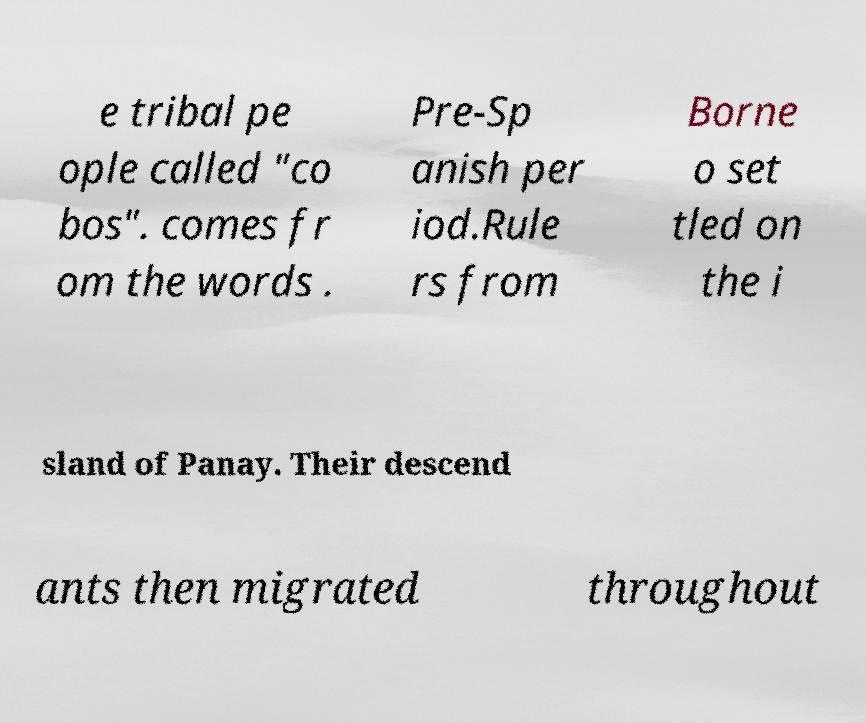Please read and relay the text visible in this image. What does it say? e tribal pe ople called "co bos". comes fr om the words . Pre-Sp anish per iod.Rule rs from Borne o set tled on the i sland of Panay. Their descend ants then migrated throughout 